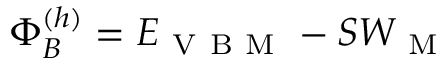<formula> <loc_0><loc_0><loc_500><loc_500>\Phi _ { B } ^ { ( h ) } = E _ { V B M } - S W _ { M }</formula> 